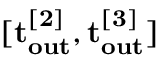<formula> <loc_0><loc_0><loc_500><loc_500>[ t _ { o u t } ^ { [ 2 ] } , t _ { o u t } ^ { [ 3 ] } ]</formula> 